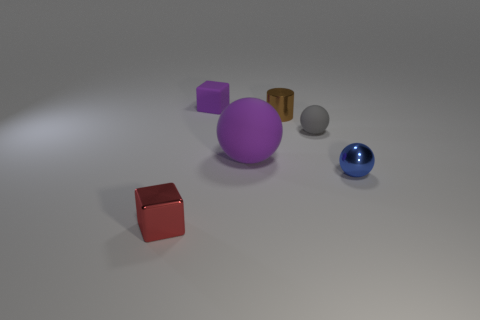What material is the object that is the same color as the matte cube?
Make the answer very short. Rubber. Does the big object have the same color as the rubber cube?
Keep it short and to the point. Yes. There is a shiny thing that is behind the rubber ball left of the small matte ball; what number of small purple rubber cubes are to the left of it?
Your response must be concise. 1. There is a object that is behind the small brown object; is it the same shape as the small red object?
Offer a terse response. Yes. Are there any small metal cylinders left of the metal thing that is on the left side of the large sphere?
Give a very brief answer. No. What number of metallic objects are there?
Provide a short and direct response. 3. The tiny metallic object that is on the left side of the gray rubber object and in front of the brown cylinder is what color?
Provide a short and direct response. Red. What is the size of the purple rubber thing that is the same shape as the small blue shiny thing?
Provide a short and direct response. Large. How many brown cylinders are the same size as the red metallic cube?
Offer a very short reply. 1. What material is the small gray sphere?
Keep it short and to the point. Rubber. 